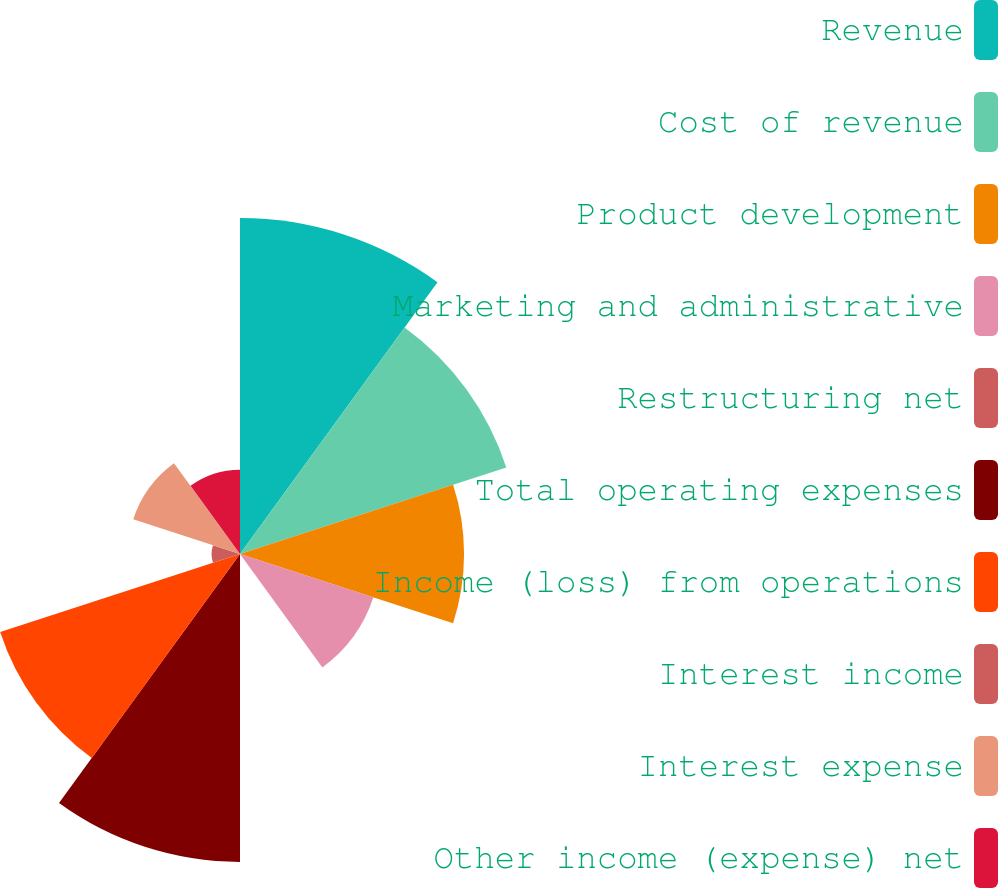Convert chart. <chart><loc_0><loc_0><loc_500><loc_500><pie_chart><fcel>Revenue<fcel>Cost of revenue<fcel>Product development<fcel>Marketing and administrative<fcel>Restructuring net<fcel>Total operating expenses<fcel>Income (loss) from operations<fcel>Interest income<fcel>Interest expense<fcel>Other income (expense) net<nl><fcel>19.03%<fcel>15.86%<fcel>12.69%<fcel>7.94%<fcel>0.02%<fcel>17.44%<fcel>14.28%<fcel>1.61%<fcel>6.36%<fcel>4.77%<nl></chart> 